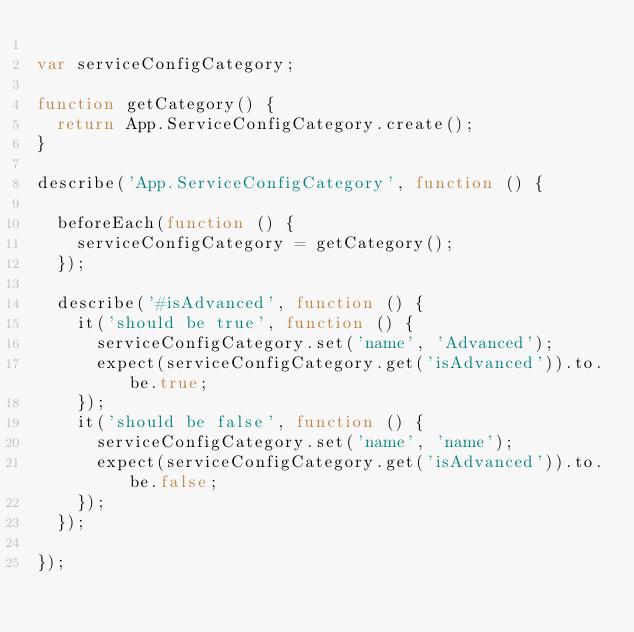Convert code to text. <code><loc_0><loc_0><loc_500><loc_500><_JavaScript_>
var serviceConfigCategory;

function getCategory() {
  return App.ServiceConfigCategory.create();
}

describe('App.ServiceConfigCategory', function () {

  beforeEach(function () {
    serviceConfigCategory = getCategory();
  });

  describe('#isAdvanced', function () {
    it('should be true', function () {
      serviceConfigCategory.set('name', 'Advanced');
      expect(serviceConfigCategory.get('isAdvanced')).to.be.true;
    });
    it('should be false', function () {
      serviceConfigCategory.set('name', 'name');
      expect(serviceConfigCategory.get('isAdvanced')).to.be.false;
    });
  });

});
</code> 